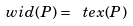Convert formula to latex. <formula><loc_0><loc_0><loc_500><loc_500>\ w i d ( P ) = \ t e x ( P )</formula> 